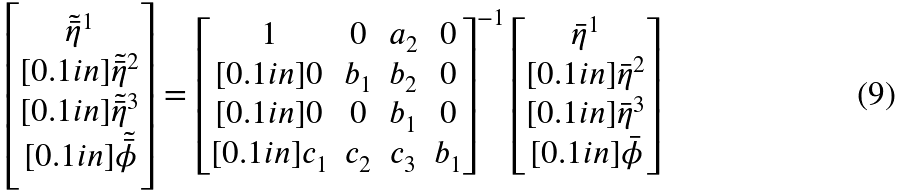Convert formula to latex. <formula><loc_0><loc_0><loc_500><loc_500>\begin{bmatrix} \tilde { \bar { \eta } } ^ { 1 } \\ [ 0 . 1 i n ] \tilde { \bar { \eta } } ^ { 2 } \\ [ 0 . 1 i n ] \tilde { \bar { \eta } } ^ { 3 } \\ [ 0 . 1 i n ] \tilde { \bar { \phi } } \end{bmatrix} = \begin{bmatrix} 1 & 0 & a _ { 2 } & 0 \\ [ 0 . 1 i n ] 0 & b _ { 1 } & b _ { 2 } & 0 \\ [ 0 . 1 i n ] 0 & 0 & b _ { 1 } & 0 \\ [ 0 . 1 i n ] c _ { 1 } & c _ { 2 } & c _ { 3 } & b _ { 1 } \end{bmatrix} ^ { - 1 } \begin{bmatrix} \bar { \eta } ^ { 1 } \\ [ 0 . 1 i n ] \bar { \eta } ^ { 2 } \\ [ 0 . 1 i n ] \bar { \eta } ^ { 3 } \\ [ 0 . 1 i n ] \bar { \phi } \end{bmatrix}</formula> 